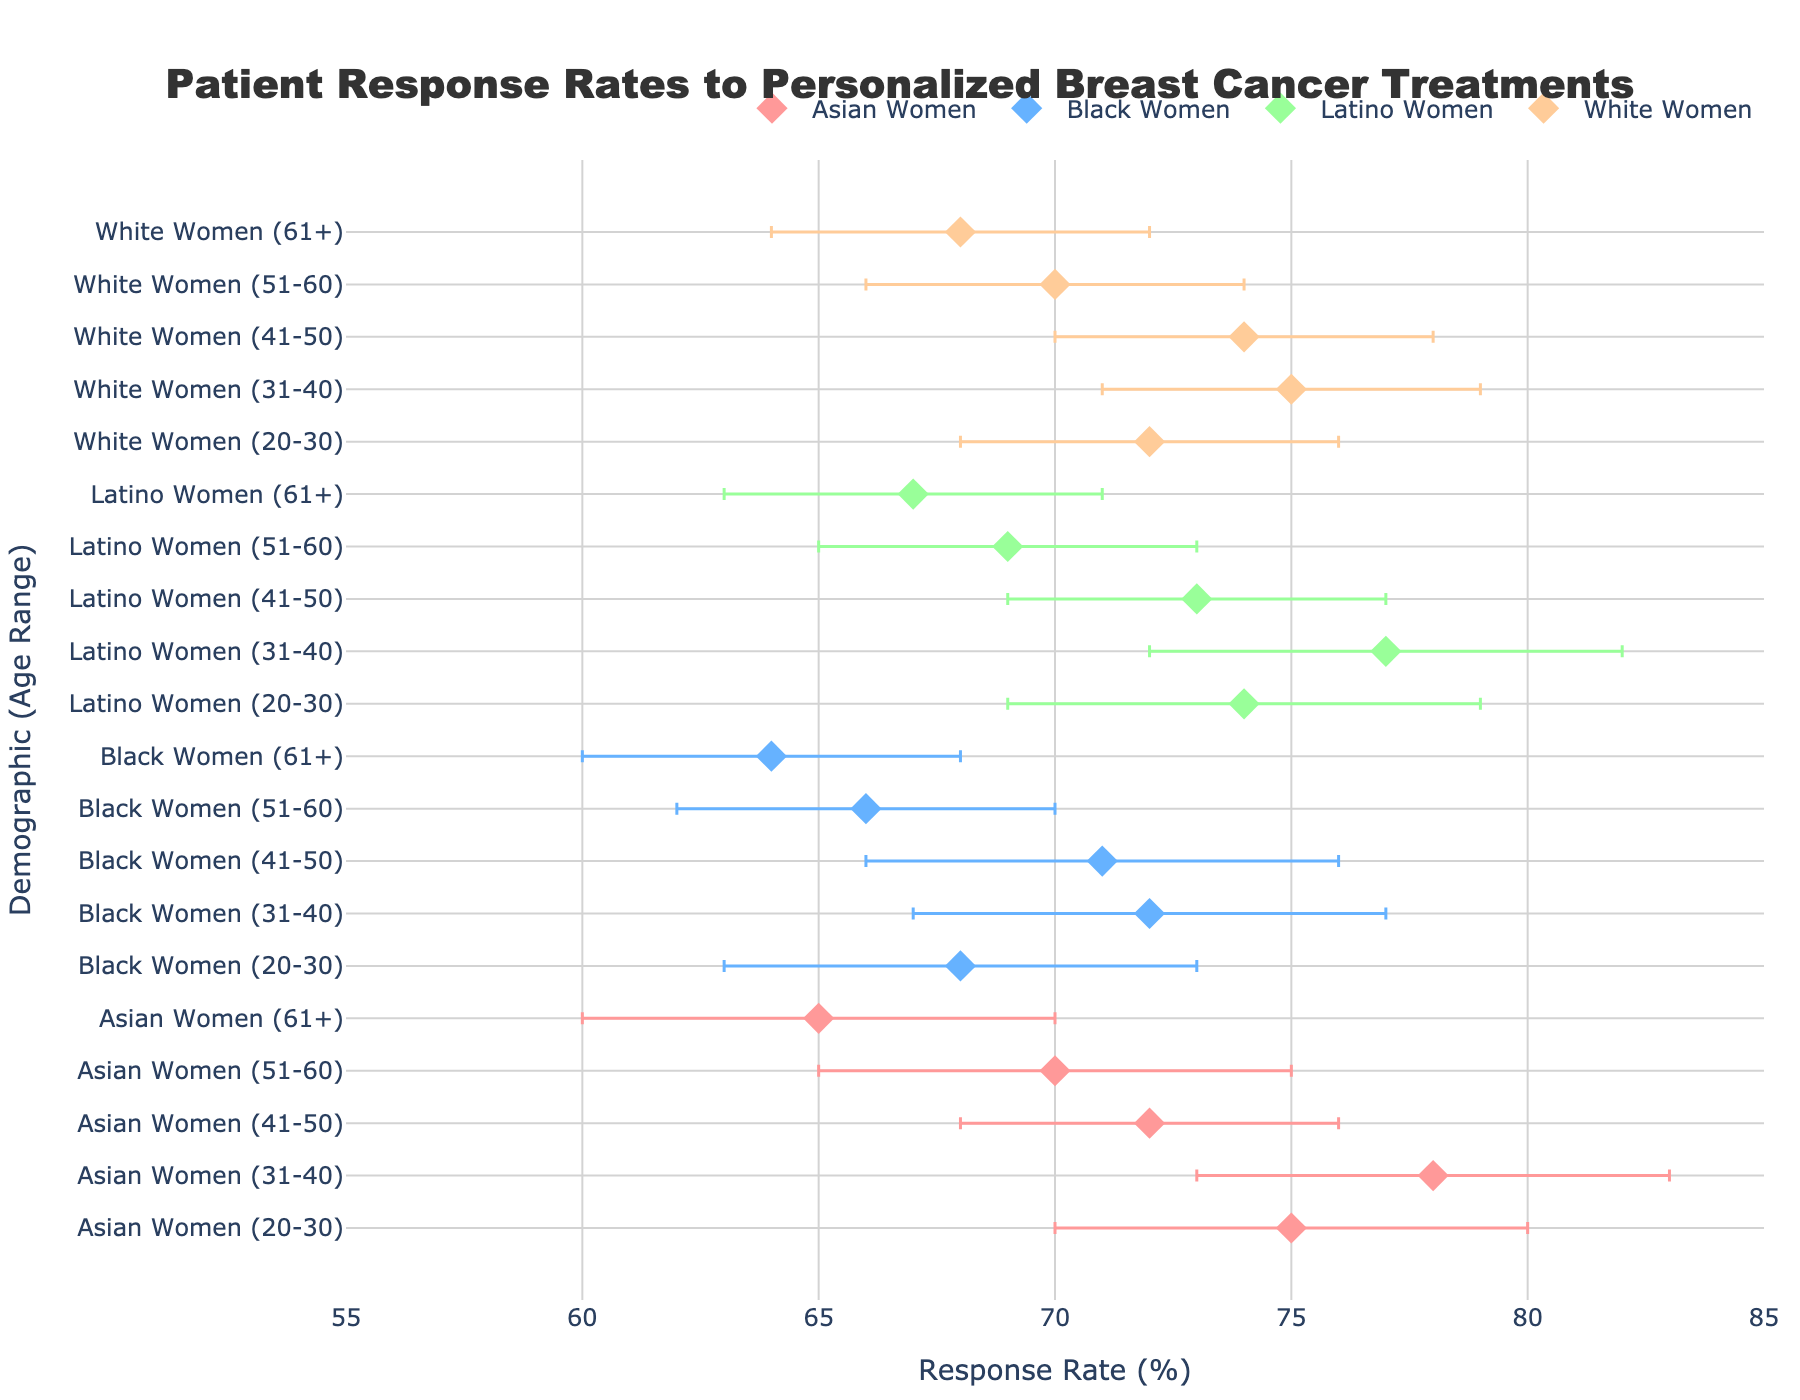What's the overall title of the figure? The title of the figure is usually prominently displayed at the top. It reads: "Patient Response Rates to Personalized Breast Cancer Treatments".
Answer: Patient Response Rates to Personalized Breast Cancer Treatments What is the response rate for Black Women aged 20-30? Locate the dot for Black Women in the 20-30 age range. The dot's corresponding value on the x-axis is 68.
Answer: 68% Which demographic group has the highest response rate among all age ranges? The highest response rate can be determined by finding the rightmost dot. Latino Women aged 31-40 have the highest response rate at 77%.
Answer: Latino Women (31-40) How does the response rate of Asian Women aged 20-30 compare to that of Black Women aged 20-30? Compare the x-axis positions of the dots for Asian Women (20-30) and Black Women (20-30). Asian Women have a response rate of 75%, while Black Women have a rate of 68%.
Answer: Asian Women aged 20-30 have a higher response rate than Black Women aged 20-30 Which age group within Latino Women has the lowest response rate? Look at the positions of the dots within the Latino Women demographic. The leftmost dot for Latino Women is for the 51-60 age range with a response rate of 69%.
Answer: 51-60 What is the range of response rates for White Women aged 31-40? Check the error bars for White Women aged 31-40. The lower bound is 71% and the upper bound is 79%, so the range is 79% - 71% = 8%.
Answer: 8% Across all demographics, which age group generally has the lowest response rates? Evaluate the positions of the dots across all demographics. The leftmost general age group across the demographics is 61+.
Answer: 61+ What is the average response rate for White Women across all age groups? Calculate the average by summing the response rates for White Women (72, 75, 74, 70, and 68) and dividing by the number of age groups (5). (72 + 75 + 74 + 70 + 68) / 5 = 71.8
Answer: 71.8% How does the range of response rates for Asian Women aged 31-40 compare to Asian Women aged 51-60? For Asian Women (31-40), the range is 83% - 73% = 10%. For Asian Women (51-60), the range is 75% - 65% = 10%. Both ranges are equal.
Answer: Both ranges are equal at 10% What is the median response rate for Black Women across all age ranges? List the response rates for Black Women (68, 72, 71, 66, and 64). Ordering these gives (64, 66, 68, 71, 72). The median value, the middle number in an ordered list, is 68.
Answer: 68% 